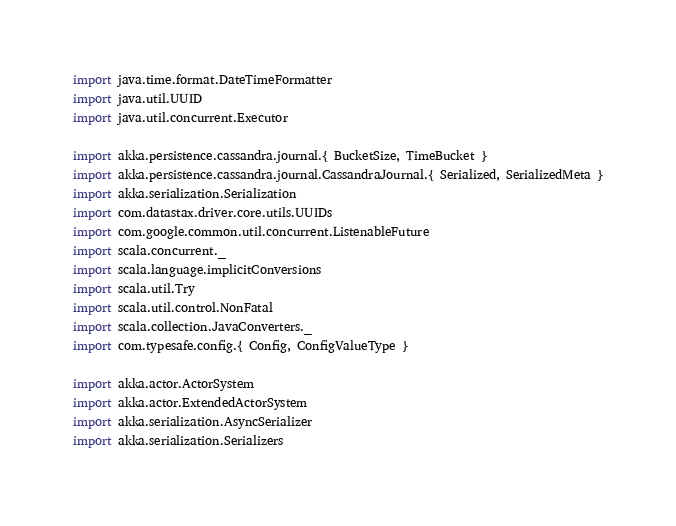Convert code to text. <code><loc_0><loc_0><loc_500><loc_500><_Scala_>import java.time.format.DateTimeFormatter
import java.util.UUID
import java.util.concurrent.Executor

import akka.persistence.cassandra.journal.{ BucketSize, TimeBucket }
import akka.persistence.cassandra.journal.CassandraJournal.{ Serialized, SerializedMeta }
import akka.serialization.Serialization
import com.datastax.driver.core.utils.UUIDs
import com.google.common.util.concurrent.ListenableFuture
import scala.concurrent._
import scala.language.implicitConversions
import scala.util.Try
import scala.util.control.NonFatal
import scala.collection.JavaConverters._
import com.typesafe.config.{ Config, ConfigValueType }

import akka.actor.ActorSystem
import akka.actor.ExtendedActorSystem
import akka.serialization.AsyncSerializer
import akka.serialization.Serializers</code> 